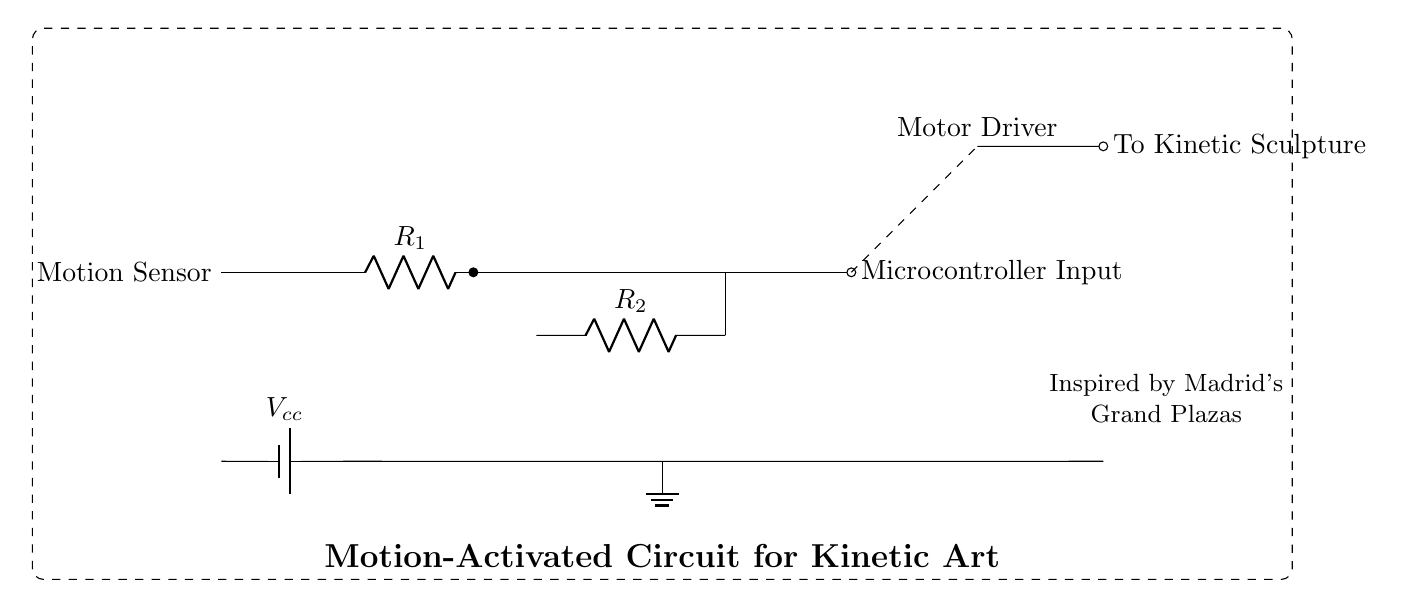What component detects motion in this circuit? The motion sensor is the component responsible for detecting motion, as indicated in the circuit diagram.
Answer: Motion Sensor What is the purpose of the amplifier? The amplifier increases the signal from the motion sensor to a suitable level for the microcontroller to interpret the input accurately.
Answer: Signal amplification What is the role of the microcontroller in this circuit? The microcontroller processes the input from the motion sensor and sends commands to the motor driver to activate the kinetic sculpture.
Answer: Control of the motor driver Which component powers the circuit? The battery provides the necessary voltage for the circuit, as shown in the diagram, connecting to the ground and powering other components.
Answer: Battery How many resistors are present in the circuit? Two resistors are indicated in the circuit, labeled R1 and R2.
Answer: Two What connection type is used from the microcontroller to the motor driver? A dashed line indicates a non-physical connection or control signal between the microcontroller and the motor driver, representing communication.
Answer: Dashed connection How does the circuit respond to motion? When motion is detected by the motion sensor, it sends a signal to the amplifier, which increases the signal strength for the microcontroller, resulting in an action from the motor driver to activate the kinetic sculpture.
Answer: Motion activates the sculpture 